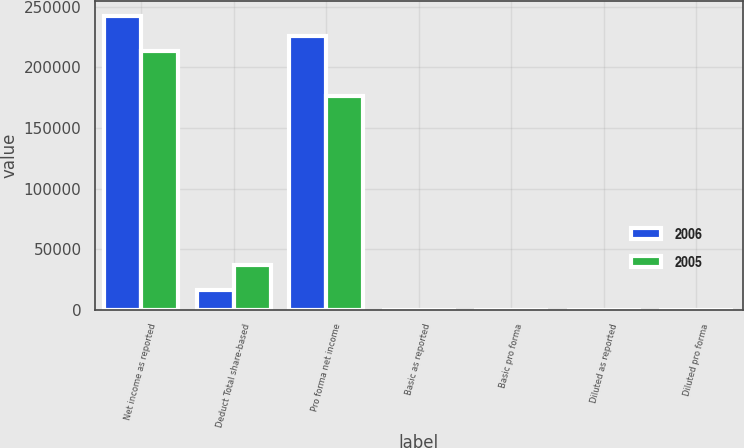<chart> <loc_0><loc_0><loc_500><loc_500><stacked_bar_chart><ecel><fcel>Net income as reported<fcel>Deduct Total share-based<fcel>Pro forma net income<fcel>Basic as reported<fcel>Basic pro forma<fcel>Diluted as reported<fcel>Diluted pro forma<nl><fcel>2006<fcel>242369<fcel>16240<fcel>226129<fcel>1.15<fcel>1.08<fcel>1.13<fcel>1.05<nl><fcel>2005<fcel>213785<fcel>37211<fcel>176574<fcel>1.03<fcel>0.85<fcel>1.01<fcel>0.83<nl></chart> 